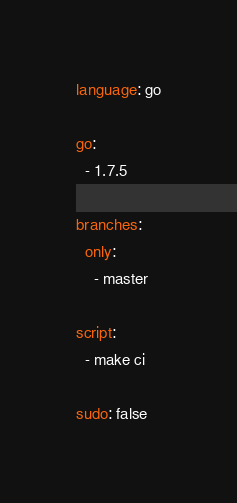Convert code to text. <code><loc_0><loc_0><loc_500><loc_500><_YAML_>language: go

go:
  - 1.7.5

branches:
  only:
    - master

script:
  - make ci

sudo: false
</code> 